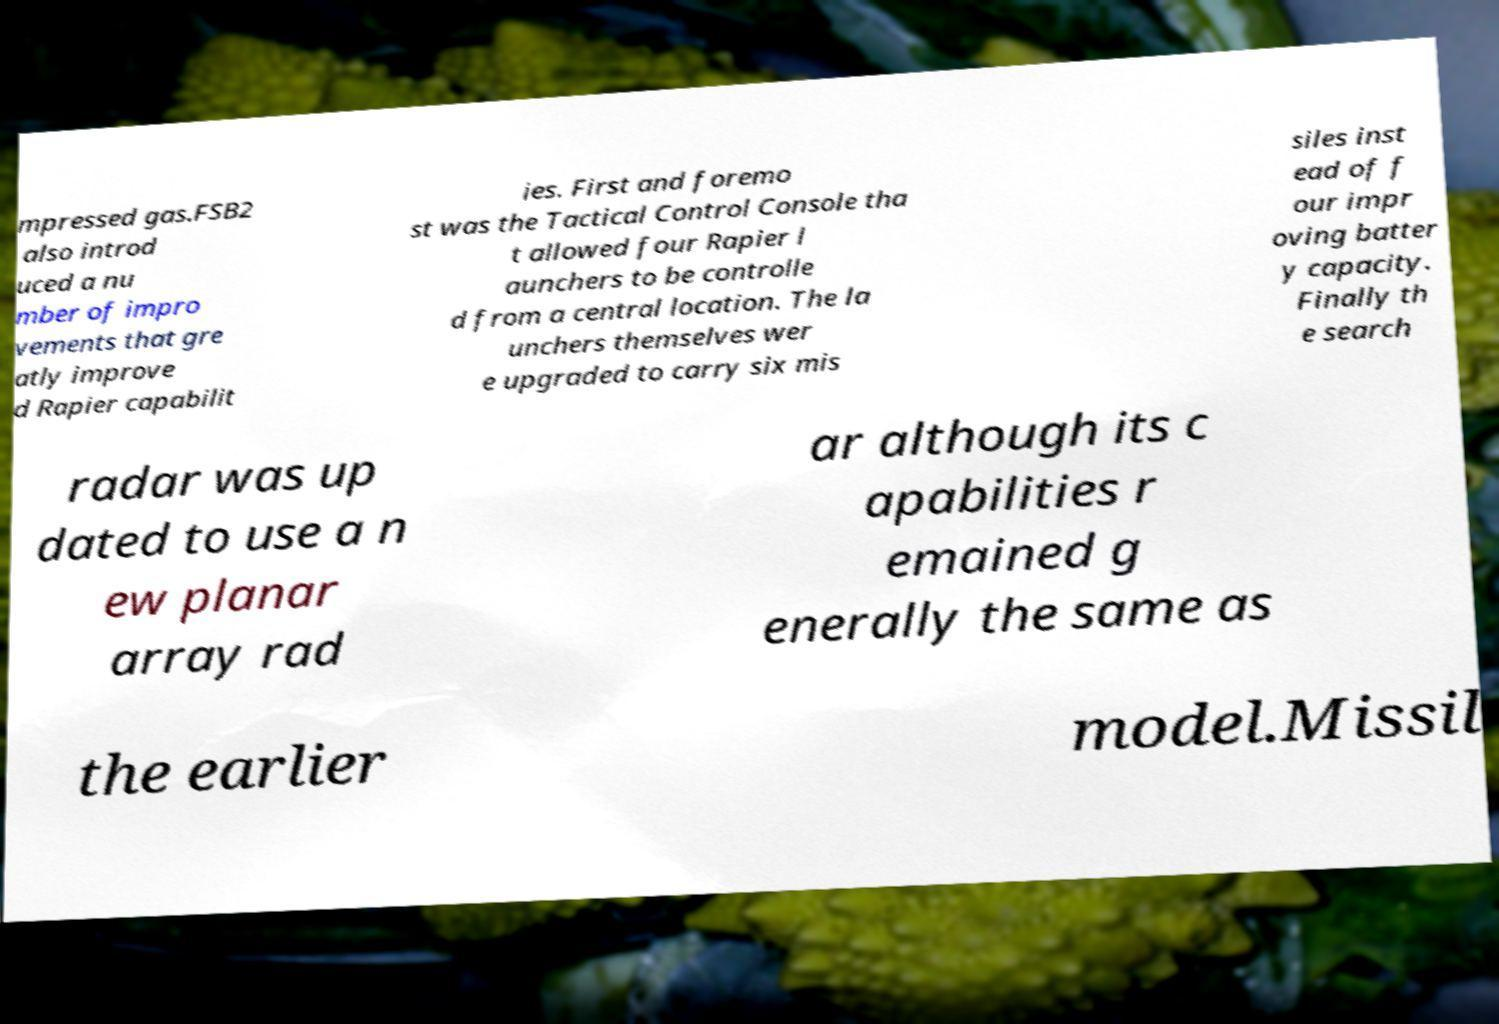Could you assist in decoding the text presented in this image and type it out clearly? mpressed gas.FSB2 also introd uced a nu mber of impro vements that gre atly improve d Rapier capabilit ies. First and foremo st was the Tactical Control Console tha t allowed four Rapier l aunchers to be controlle d from a central location. The la unchers themselves wer e upgraded to carry six mis siles inst ead of f our impr oving batter y capacity. Finally th e search radar was up dated to use a n ew planar array rad ar although its c apabilities r emained g enerally the same as the earlier model.Missil 